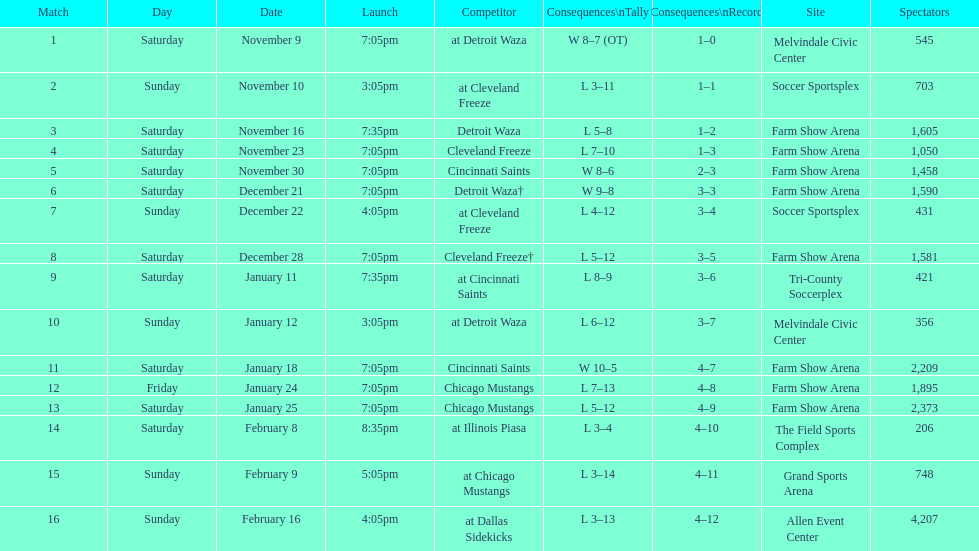Which opponent is listed first in the table? Detroit Waza. 